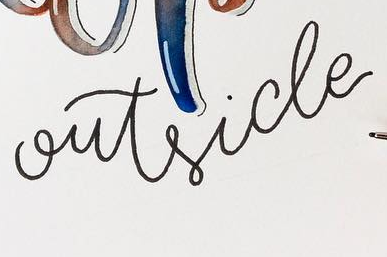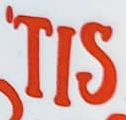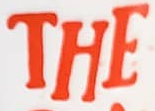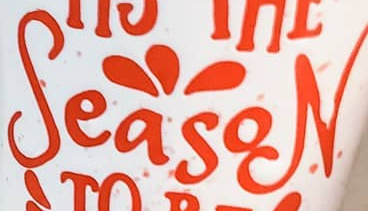Read the text from these images in sequence, separated by a semicolon. outside; 'TIS; THE; SeasoN 